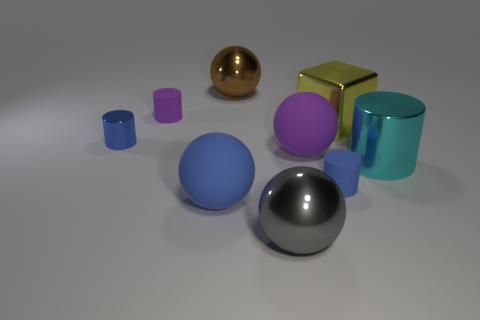There is a sphere right of the gray shiny sphere; does it have the same size as the blue sphere that is left of the brown thing?
Your answer should be compact. Yes. Are there any big rubber objects in front of the purple ball?
Offer a very short reply. Yes. What is the color of the shiny sphere that is behind the rubber cylinder that is on the right side of the large blue object?
Keep it short and to the point. Brown. Is the number of tiny cyan matte cylinders less than the number of blue rubber spheres?
Ensure brevity in your answer.  Yes. How many other gray metallic objects are the same shape as the gray metallic thing?
Provide a short and direct response. 0. What color is the other rubber ball that is the same size as the blue matte sphere?
Provide a short and direct response. Purple. Are there the same number of large brown shiny balls in front of the tiny purple rubber cylinder and metallic objects that are to the right of the big metal cube?
Ensure brevity in your answer.  No. Is there another brown metallic ball of the same size as the brown ball?
Offer a very short reply. No. The cyan cylinder has what size?
Give a very brief answer. Large. Are there an equal number of spheres to the right of the large shiny block and yellow rubber spheres?
Your response must be concise. Yes. 